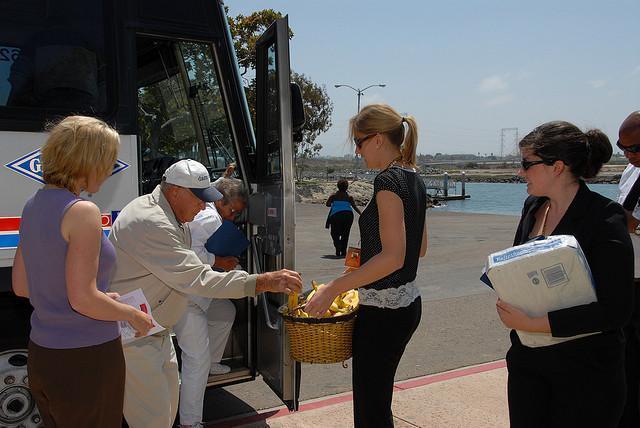How many pairs of sunglasses are there?
Give a very brief answer. 2. How many people are in the picture?
Give a very brief answer. 6. How many people are on the elephant on the right?
Give a very brief answer. 0. 